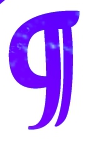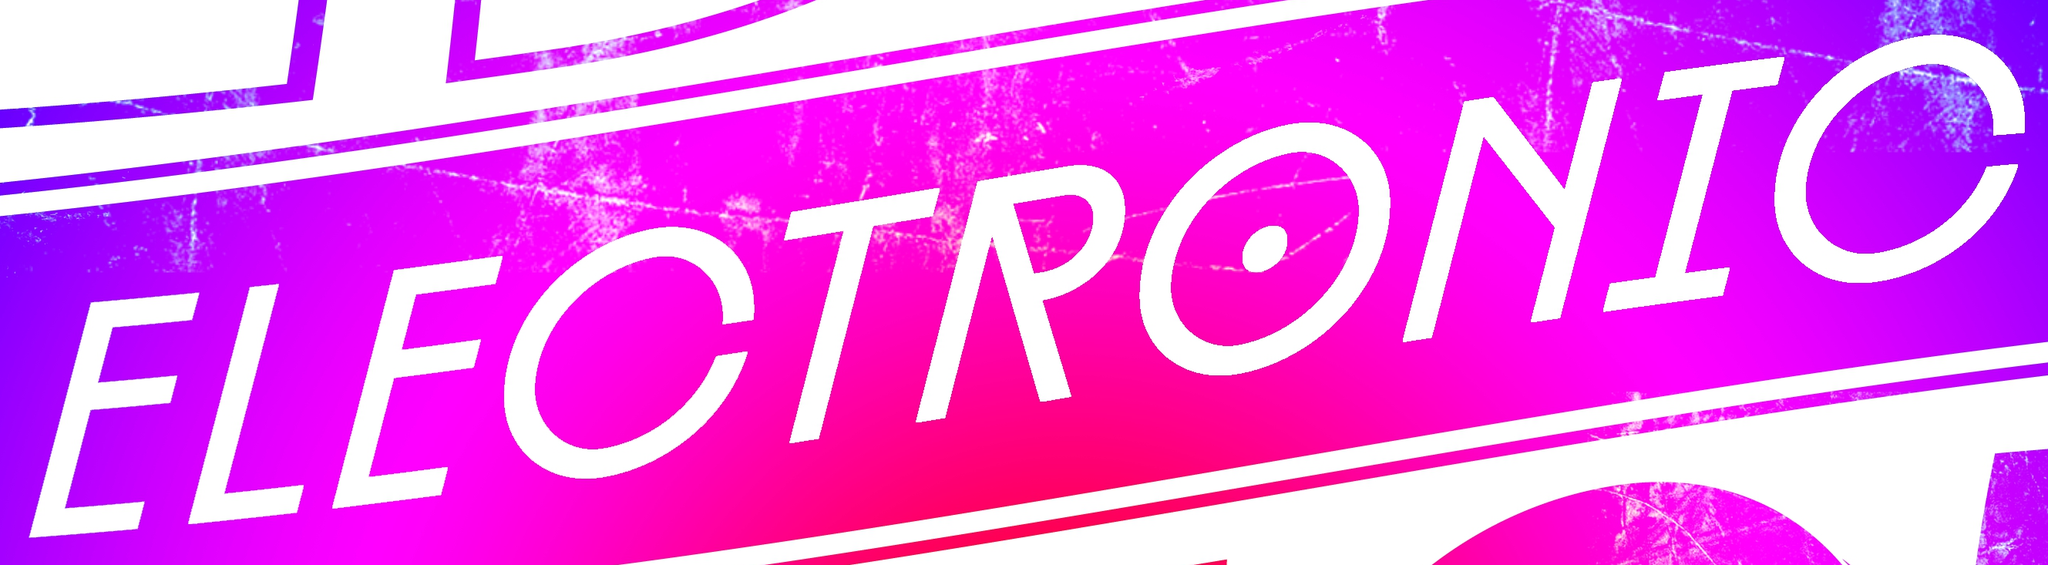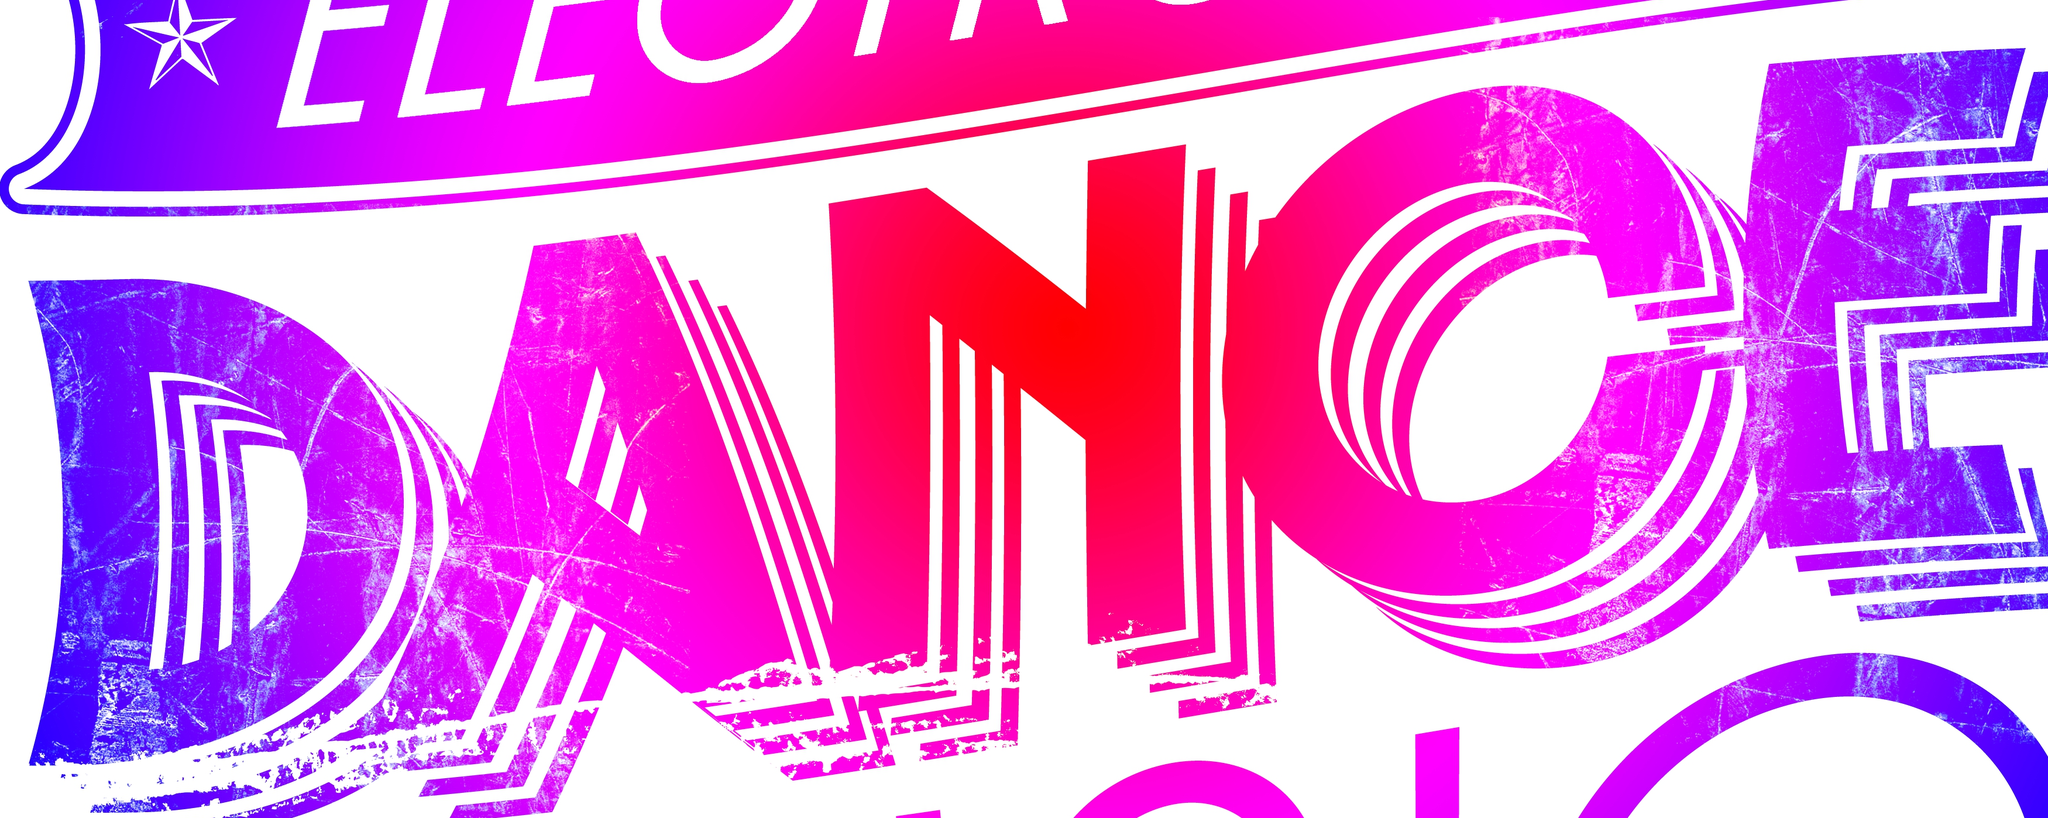Transcribe the words shown in these images in order, separated by a semicolon. g; ELECTRONIC; DANCE 